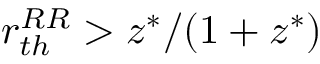<formula> <loc_0><loc_0><loc_500><loc_500>r _ { t h } ^ { R R } > z ^ { * } / ( 1 + z ^ { * } )</formula> 